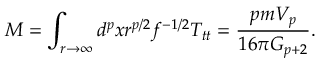<formula> <loc_0><loc_0><loc_500><loc_500>M = \int _ { r \rightarrow \infty } d ^ { p } x r ^ { p / 2 } f ^ { - 1 / 2 } T _ { t t } = \frac { p m V _ { p } } { 1 6 \pi G _ { p + 2 } } .</formula> 